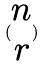Convert formula to latex. <formula><loc_0><loc_0><loc_500><loc_500>( \begin{matrix} n \\ r \end{matrix} )</formula> 